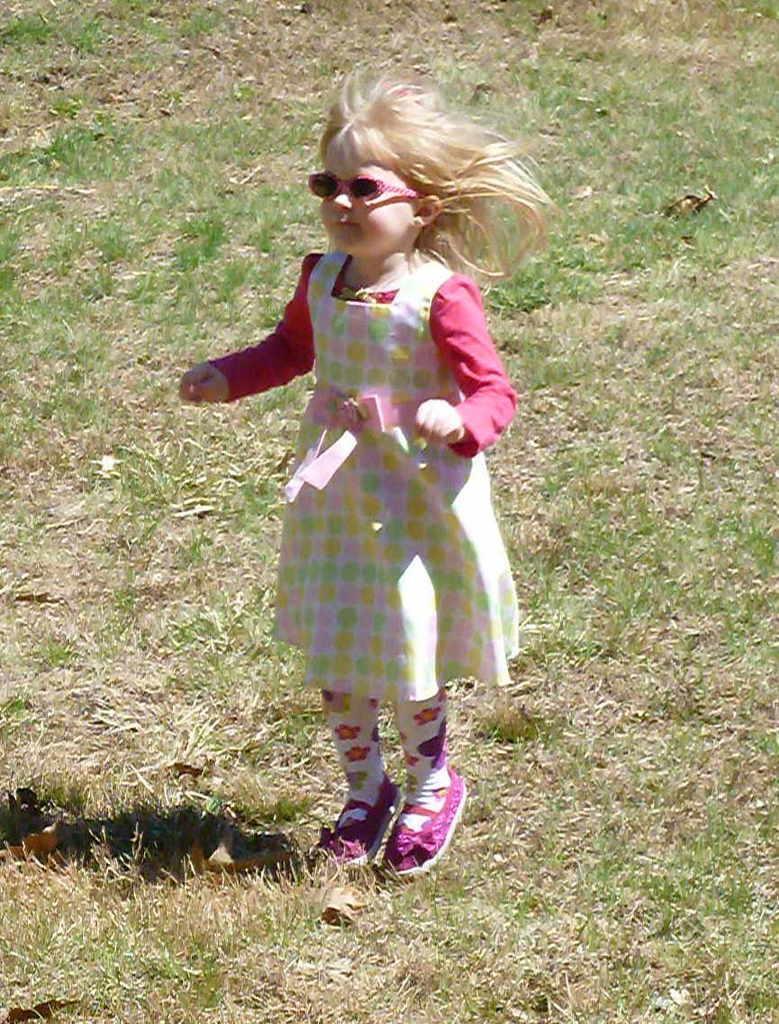Can you describe this image briefly? This image is taken outdoors. At the bottom of the image there is a ground with grass on it. In the middle of the image a girl jumps on the ground and she is with a short hair. 